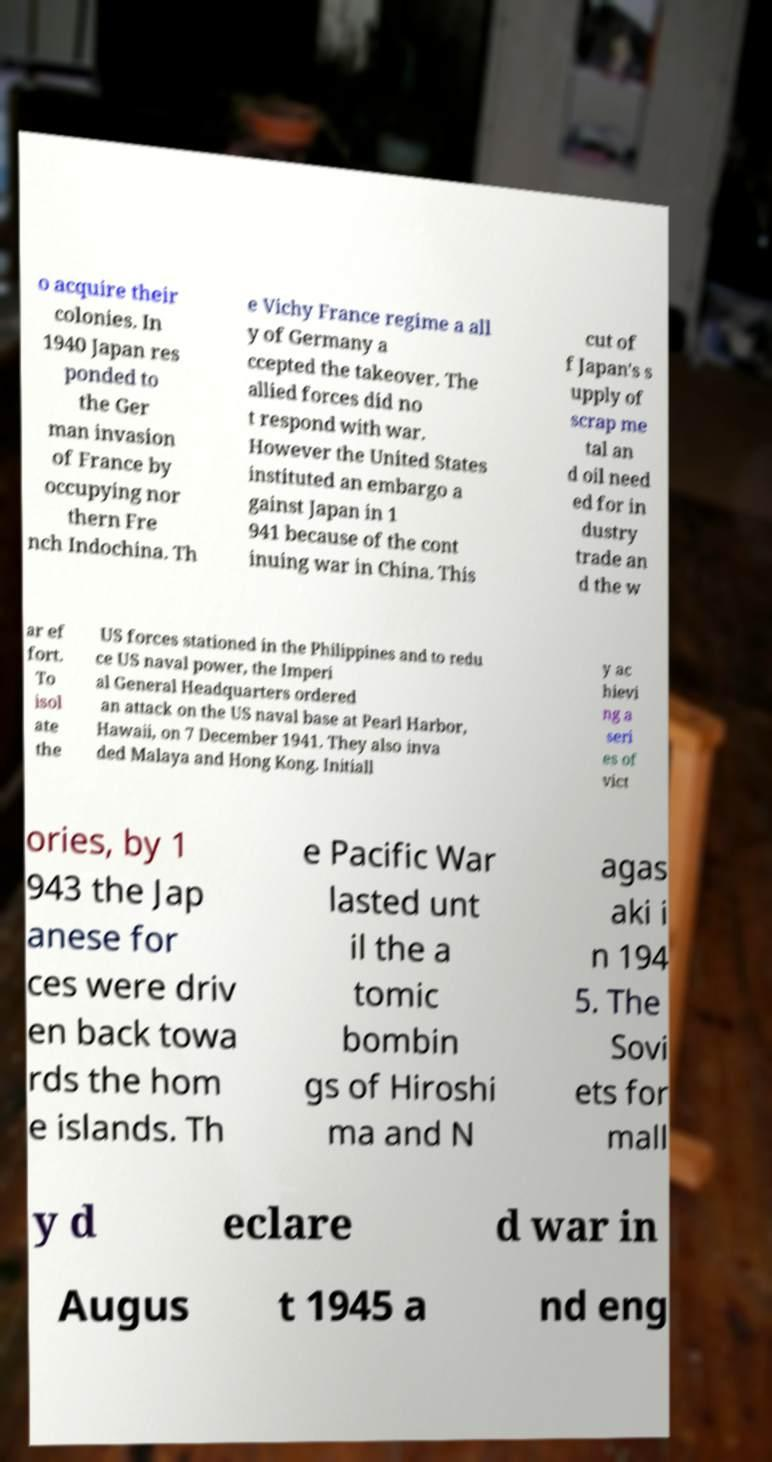Please identify and transcribe the text found in this image. o acquire their colonies. In 1940 Japan res ponded to the Ger man invasion of France by occupying nor thern Fre nch Indochina. Th e Vichy France regime a all y of Germany a ccepted the takeover. The allied forces did no t respond with war. However the United States instituted an embargo a gainst Japan in 1 941 because of the cont inuing war in China. This cut of f Japan's s upply of scrap me tal an d oil need ed for in dustry trade an d the w ar ef fort. To isol ate the US forces stationed in the Philippines and to redu ce US naval power, the Imperi al General Headquarters ordered an attack on the US naval base at Pearl Harbor, Hawaii, on 7 December 1941. They also inva ded Malaya and Hong Kong. Initiall y ac hievi ng a seri es of vict ories, by 1 943 the Jap anese for ces were driv en back towa rds the hom e islands. Th e Pacific War lasted unt il the a tomic bombin gs of Hiroshi ma and N agas aki i n 194 5. The Sovi ets for mall y d eclare d war in Augus t 1945 a nd eng 